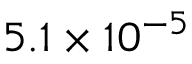<formula> <loc_0><loc_0><loc_500><loc_500>5 . 1 \times 1 0 ^ { - 5 }</formula> 